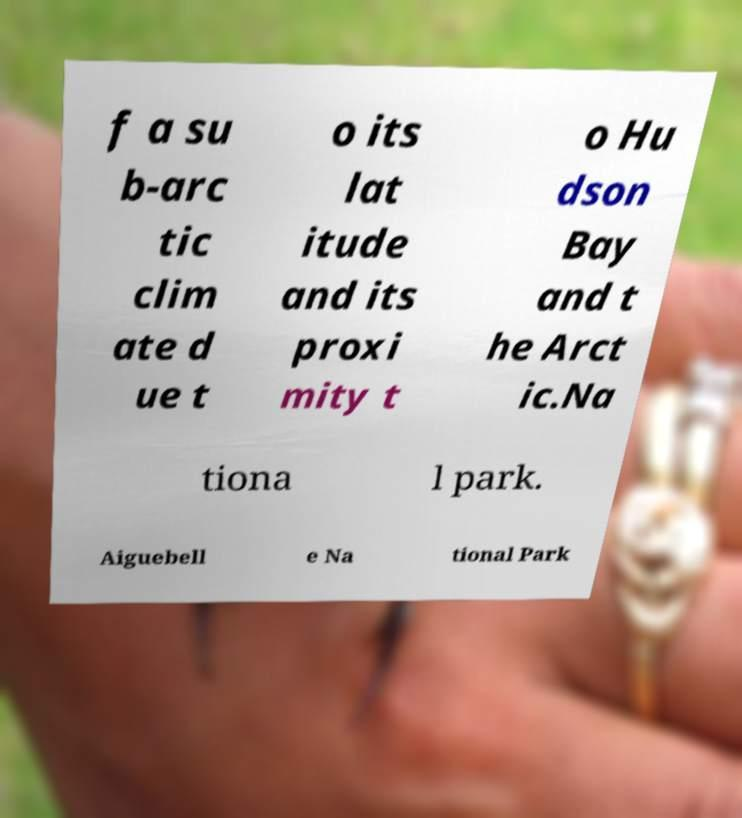Can you accurately transcribe the text from the provided image for me? f a su b-arc tic clim ate d ue t o its lat itude and its proxi mity t o Hu dson Bay and t he Arct ic.Na tiona l park. Aiguebell e Na tional Park 